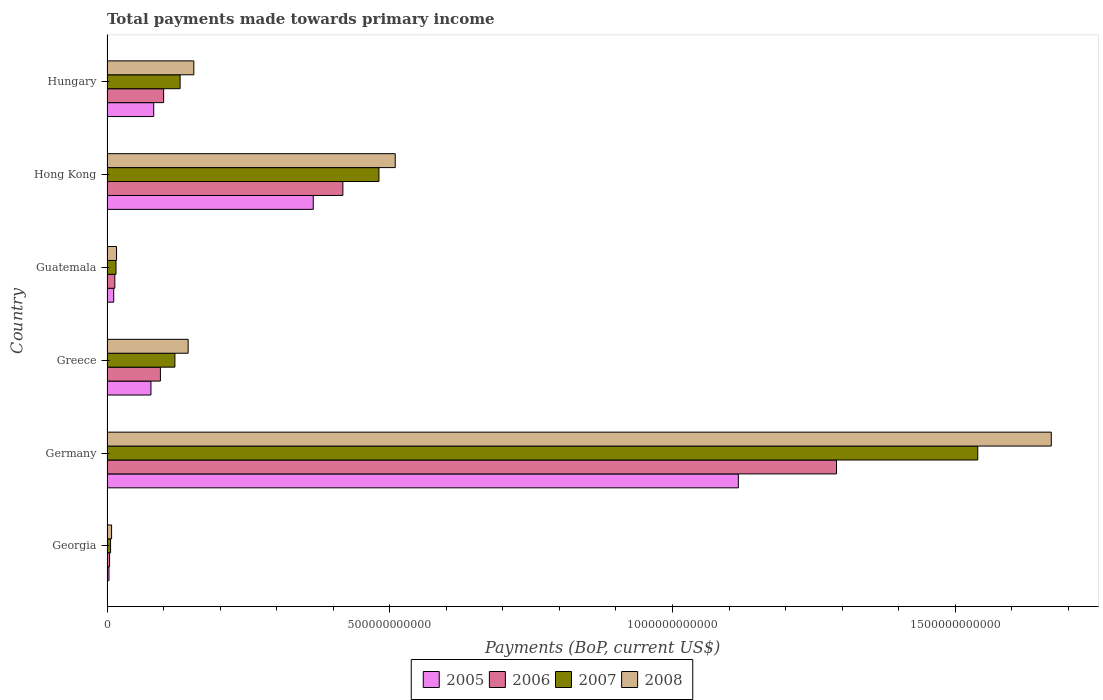How many different coloured bars are there?
Offer a very short reply. 4. How many groups of bars are there?
Give a very brief answer. 6. How many bars are there on the 3rd tick from the top?
Your answer should be compact. 4. How many bars are there on the 2nd tick from the bottom?
Provide a succinct answer. 4. What is the label of the 6th group of bars from the top?
Your answer should be compact. Georgia. What is the total payments made towards primary income in 2005 in Hong Kong?
Your answer should be compact. 3.65e+11. Across all countries, what is the maximum total payments made towards primary income in 2005?
Your answer should be very brief. 1.12e+12. Across all countries, what is the minimum total payments made towards primary income in 2005?
Your answer should be compact. 3.47e+09. In which country was the total payments made towards primary income in 2007 minimum?
Your response must be concise. Georgia. What is the total total payments made towards primary income in 2005 in the graph?
Offer a terse response. 1.66e+12. What is the difference between the total payments made towards primary income in 2007 in Georgia and that in Hong Kong?
Your answer should be compact. -4.75e+11. What is the difference between the total payments made towards primary income in 2008 in Georgia and the total payments made towards primary income in 2005 in Hong Kong?
Provide a short and direct response. -3.57e+11. What is the average total payments made towards primary income in 2008 per country?
Ensure brevity in your answer.  4.17e+11. What is the difference between the total payments made towards primary income in 2006 and total payments made towards primary income in 2007 in Greece?
Your answer should be compact. -2.56e+1. In how many countries, is the total payments made towards primary income in 2006 greater than 800000000000 US$?
Offer a terse response. 1. What is the ratio of the total payments made towards primary income in 2006 in Georgia to that in Greece?
Your answer should be very brief. 0.05. Is the total payments made towards primary income in 2008 in Georgia less than that in Hong Kong?
Offer a very short reply. Yes. What is the difference between the highest and the second highest total payments made towards primary income in 2007?
Give a very brief answer. 1.06e+12. What is the difference between the highest and the lowest total payments made towards primary income in 2006?
Give a very brief answer. 1.29e+12. Is the sum of the total payments made towards primary income in 2005 in Greece and Hungary greater than the maximum total payments made towards primary income in 2007 across all countries?
Give a very brief answer. No. What does the 3rd bar from the top in Hong Kong represents?
Give a very brief answer. 2006. How many bars are there?
Make the answer very short. 24. What is the difference between two consecutive major ticks on the X-axis?
Give a very brief answer. 5.00e+11. Are the values on the major ticks of X-axis written in scientific E-notation?
Your answer should be compact. No. Does the graph contain any zero values?
Make the answer very short. No. Does the graph contain grids?
Offer a terse response. No. Where does the legend appear in the graph?
Provide a short and direct response. Bottom center. How are the legend labels stacked?
Keep it short and to the point. Horizontal. What is the title of the graph?
Provide a short and direct response. Total payments made towards primary income. Does "1961" appear as one of the legend labels in the graph?
Provide a short and direct response. No. What is the label or title of the X-axis?
Your response must be concise. Payments (BoP, current US$). What is the label or title of the Y-axis?
Provide a succinct answer. Country. What is the Payments (BoP, current US$) of 2005 in Georgia?
Your answer should be very brief. 3.47e+09. What is the Payments (BoP, current US$) in 2006 in Georgia?
Your response must be concise. 4.56e+09. What is the Payments (BoP, current US$) of 2007 in Georgia?
Your response must be concise. 6.32e+09. What is the Payments (BoP, current US$) in 2008 in Georgia?
Your answer should be very brief. 8.11e+09. What is the Payments (BoP, current US$) of 2005 in Germany?
Your answer should be compact. 1.12e+12. What is the Payments (BoP, current US$) in 2006 in Germany?
Your answer should be compact. 1.29e+12. What is the Payments (BoP, current US$) in 2007 in Germany?
Offer a very short reply. 1.54e+12. What is the Payments (BoP, current US$) of 2008 in Germany?
Make the answer very short. 1.67e+12. What is the Payments (BoP, current US$) of 2005 in Greece?
Offer a terse response. 7.77e+1. What is the Payments (BoP, current US$) in 2006 in Greece?
Your response must be concise. 9.44e+1. What is the Payments (BoP, current US$) of 2007 in Greece?
Give a very brief answer. 1.20e+11. What is the Payments (BoP, current US$) of 2008 in Greece?
Provide a succinct answer. 1.44e+11. What is the Payments (BoP, current US$) of 2005 in Guatemala?
Give a very brief answer. 1.19e+1. What is the Payments (BoP, current US$) of 2006 in Guatemala?
Your response must be concise. 1.38e+1. What is the Payments (BoP, current US$) of 2007 in Guatemala?
Offer a terse response. 1.59e+1. What is the Payments (BoP, current US$) in 2008 in Guatemala?
Give a very brief answer. 1.69e+1. What is the Payments (BoP, current US$) in 2005 in Hong Kong?
Keep it short and to the point. 3.65e+11. What is the Payments (BoP, current US$) in 2006 in Hong Kong?
Your answer should be compact. 4.17e+11. What is the Payments (BoP, current US$) in 2007 in Hong Kong?
Offer a very short reply. 4.81e+11. What is the Payments (BoP, current US$) of 2008 in Hong Kong?
Provide a short and direct response. 5.10e+11. What is the Payments (BoP, current US$) in 2005 in Hungary?
Provide a short and direct response. 8.26e+1. What is the Payments (BoP, current US$) of 2006 in Hungary?
Provide a short and direct response. 1.00e+11. What is the Payments (BoP, current US$) in 2007 in Hungary?
Keep it short and to the point. 1.29e+11. What is the Payments (BoP, current US$) of 2008 in Hungary?
Provide a short and direct response. 1.54e+11. Across all countries, what is the maximum Payments (BoP, current US$) of 2005?
Offer a very short reply. 1.12e+12. Across all countries, what is the maximum Payments (BoP, current US$) in 2006?
Your response must be concise. 1.29e+12. Across all countries, what is the maximum Payments (BoP, current US$) of 2007?
Keep it short and to the point. 1.54e+12. Across all countries, what is the maximum Payments (BoP, current US$) of 2008?
Provide a succinct answer. 1.67e+12. Across all countries, what is the minimum Payments (BoP, current US$) of 2005?
Your answer should be very brief. 3.47e+09. Across all countries, what is the minimum Payments (BoP, current US$) in 2006?
Your answer should be very brief. 4.56e+09. Across all countries, what is the minimum Payments (BoP, current US$) in 2007?
Ensure brevity in your answer.  6.32e+09. Across all countries, what is the minimum Payments (BoP, current US$) of 2008?
Give a very brief answer. 8.11e+09. What is the total Payments (BoP, current US$) of 2005 in the graph?
Offer a very short reply. 1.66e+12. What is the total Payments (BoP, current US$) in 2006 in the graph?
Your answer should be compact. 1.92e+12. What is the total Payments (BoP, current US$) of 2007 in the graph?
Make the answer very short. 2.29e+12. What is the total Payments (BoP, current US$) in 2008 in the graph?
Keep it short and to the point. 2.50e+12. What is the difference between the Payments (BoP, current US$) in 2005 in Georgia and that in Germany?
Make the answer very short. -1.11e+12. What is the difference between the Payments (BoP, current US$) in 2006 in Georgia and that in Germany?
Your answer should be compact. -1.29e+12. What is the difference between the Payments (BoP, current US$) in 2007 in Georgia and that in Germany?
Provide a short and direct response. -1.53e+12. What is the difference between the Payments (BoP, current US$) of 2008 in Georgia and that in Germany?
Offer a very short reply. -1.66e+12. What is the difference between the Payments (BoP, current US$) of 2005 in Georgia and that in Greece?
Make the answer very short. -7.43e+1. What is the difference between the Payments (BoP, current US$) in 2006 in Georgia and that in Greece?
Provide a short and direct response. -8.99e+1. What is the difference between the Payments (BoP, current US$) in 2007 in Georgia and that in Greece?
Your answer should be compact. -1.14e+11. What is the difference between the Payments (BoP, current US$) of 2008 in Georgia and that in Greece?
Make the answer very short. -1.35e+11. What is the difference between the Payments (BoP, current US$) in 2005 in Georgia and that in Guatemala?
Provide a succinct answer. -8.42e+09. What is the difference between the Payments (BoP, current US$) of 2006 in Georgia and that in Guatemala?
Offer a terse response. -9.27e+09. What is the difference between the Payments (BoP, current US$) in 2007 in Georgia and that in Guatemala?
Give a very brief answer. -9.59e+09. What is the difference between the Payments (BoP, current US$) in 2008 in Georgia and that in Guatemala?
Offer a very short reply. -8.77e+09. What is the difference between the Payments (BoP, current US$) in 2005 in Georgia and that in Hong Kong?
Offer a very short reply. -3.61e+11. What is the difference between the Payments (BoP, current US$) in 2006 in Georgia and that in Hong Kong?
Your response must be concise. -4.13e+11. What is the difference between the Payments (BoP, current US$) in 2007 in Georgia and that in Hong Kong?
Provide a succinct answer. -4.75e+11. What is the difference between the Payments (BoP, current US$) in 2008 in Georgia and that in Hong Kong?
Ensure brevity in your answer.  -5.02e+11. What is the difference between the Payments (BoP, current US$) in 2005 in Georgia and that in Hungary?
Your response must be concise. -7.91e+1. What is the difference between the Payments (BoP, current US$) in 2006 in Georgia and that in Hungary?
Your answer should be very brief. -9.56e+1. What is the difference between the Payments (BoP, current US$) of 2007 in Georgia and that in Hungary?
Give a very brief answer. -1.23e+11. What is the difference between the Payments (BoP, current US$) of 2008 in Georgia and that in Hungary?
Keep it short and to the point. -1.45e+11. What is the difference between the Payments (BoP, current US$) in 2005 in Germany and that in Greece?
Offer a very short reply. 1.04e+12. What is the difference between the Payments (BoP, current US$) of 2006 in Germany and that in Greece?
Offer a very short reply. 1.20e+12. What is the difference between the Payments (BoP, current US$) in 2007 in Germany and that in Greece?
Offer a terse response. 1.42e+12. What is the difference between the Payments (BoP, current US$) of 2008 in Germany and that in Greece?
Offer a very short reply. 1.53e+12. What is the difference between the Payments (BoP, current US$) in 2005 in Germany and that in Guatemala?
Make the answer very short. 1.10e+12. What is the difference between the Payments (BoP, current US$) in 2006 in Germany and that in Guatemala?
Give a very brief answer. 1.28e+12. What is the difference between the Payments (BoP, current US$) in 2007 in Germany and that in Guatemala?
Make the answer very short. 1.52e+12. What is the difference between the Payments (BoP, current US$) of 2008 in Germany and that in Guatemala?
Offer a terse response. 1.65e+12. What is the difference between the Payments (BoP, current US$) in 2005 in Germany and that in Hong Kong?
Your answer should be very brief. 7.52e+11. What is the difference between the Payments (BoP, current US$) in 2006 in Germany and that in Hong Kong?
Your answer should be very brief. 8.73e+11. What is the difference between the Payments (BoP, current US$) in 2007 in Germany and that in Hong Kong?
Keep it short and to the point. 1.06e+12. What is the difference between the Payments (BoP, current US$) in 2008 in Germany and that in Hong Kong?
Keep it short and to the point. 1.16e+12. What is the difference between the Payments (BoP, current US$) of 2005 in Germany and that in Hungary?
Your answer should be very brief. 1.03e+12. What is the difference between the Payments (BoP, current US$) of 2006 in Germany and that in Hungary?
Offer a terse response. 1.19e+12. What is the difference between the Payments (BoP, current US$) of 2007 in Germany and that in Hungary?
Make the answer very short. 1.41e+12. What is the difference between the Payments (BoP, current US$) of 2008 in Germany and that in Hungary?
Ensure brevity in your answer.  1.52e+12. What is the difference between the Payments (BoP, current US$) of 2005 in Greece and that in Guatemala?
Keep it short and to the point. 6.58e+1. What is the difference between the Payments (BoP, current US$) of 2006 in Greece and that in Guatemala?
Your answer should be compact. 8.06e+1. What is the difference between the Payments (BoP, current US$) of 2007 in Greece and that in Guatemala?
Keep it short and to the point. 1.04e+11. What is the difference between the Payments (BoP, current US$) in 2008 in Greece and that in Guatemala?
Keep it short and to the point. 1.27e+11. What is the difference between the Payments (BoP, current US$) in 2005 in Greece and that in Hong Kong?
Give a very brief answer. -2.87e+11. What is the difference between the Payments (BoP, current US$) in 2006 in Greece and that in Hong Kong?
Ensure brevity in your answer.  -3.23e+11. What is the difference between the Payments (BoP, current US$) of 2007 in Greece and that in Hong Kong?
Give a very brief answer. -3.61e+11. What is the difference between the Payments (BoP, current US$) in 2008 in Greece and that in Hong Kong?
Your response must be concise. -3.66e+11. What is the difference between the Payments (BoP, current US$) of 2005 in Greece and that in Hungary?
Give a very brief answer. -4.89e+09. What is the difference between the Payments (BoP, current US$) in 2006 in Greece and that in Hungary?
Your answer should be very brief. -5.71e+09. What is the difference between the Payments (BoP, current US$) of 2007 in Greece and that in Hungary?
Your response must be concise. -9.18e+09. What is the difference between the Payments (BoP, current US$) of 2008 in Greece and that in Hungary?
Your answer should be compact. -1.00e+1. What is the difference between the Payments (BoP, current US$) in 2005 in Guatemala and that in Hong Kong?
Your response must be concise. -3.53e+11. What is the difference between the Payments (BoP, current US$) of 2006 in Guatemala and that in Hong Kong?
Give a very brief answer. -4.03e+11. What is the difference between the Payments (BoP, current US$) in 2007 in Guatemala and that in Hong Kong?
Offer a very short reply. -4.65e+11. What is the difference between the Payments (BoP, current US$) in 2008 in Guatemala and that in Hong Kong?
Ensure brevity in your answer.  -4.93e+11. What is the difference between the Payments (BoP, current US$) of 2005 in Guatemala and that in Hungary?
Offer a terse response. -7.07e+1. What is the difference between the Payments (BoP, current US$) in 2006 in Guatemala and that in Hungary?
Offer a very short reply. -8.63e+1. What is the difference between the Payments (BoP, current US$) of 2007 in Guatemala and that in Hungary?
Your answer should be compact. -1.13e+11. What is the difference between the Payments (BoP, current US$) in 2008 in Guatemala and that in Hungary?
Provide a succinct answer. -1.37e+11. What is the difference between the Payments (BoP, current US$) of 2005 in Hong Kong and that in Hungary?
Provide a succinct answer. 2.82e+11. What is the difference between the Payments (BoP, current US$) in 2006 in Hong Kong and that in Hungary?
Offer a terse response. 3.17e+11. What is the difference between the Payments (BoP, current US$) in 2007 in Hong Kong and that in Hungary?
Make the answer very short. 3.52e+11. What is the difference between the Payments (BoP, current US$) in 2008 in Hong Kong and that in Hungary?
Your answer should be compact. 3.56e+11. What is the difference between the Payments (BoP, current US$) in 2005 in Georgia and the Payments (BoP, current US$) in 2006 in Germany?
Make the answer very short. -1.29e+12. What is the difference between the Payments (BoP, current US$) in 2005 in Georgia and the Payments (BoP, current US$) in 2007 in Germany?
Make the answer very short. -1.54e+12. What is the difference between the Payments (BoP, current US$) of 2005 in Georgia and the Payments (BoP, current US$) of 2008 in Germany?
Your response must be concise. -1.67e+12. What is the difference between the Payments (BoP, current US$) in 2006 in Georgia and the Payments (BoP, current US$) in 2007 in Germany?
Ensure brevity in your answer.  -1.54e+12. What is the difference between the Payments (BoP, current US$) of 2006 in Georgia and the Payments (BoP, current US$) of 2008 in Germany?
Ensure brevity in your answer.  -1.67e+12. What is the difference between the Payments (BoP, current US$) of 2007 in Georgia and the Payments (BoP, current US$) of 2008 in Germany?
Keep it short and to the point. -1.66e+12. What is the difference between the Payments (BoP, current US$) in 2005 in Georgia and the Payments (BoP, current US$) in 2006 in Greece?
Offer a very short reply. -9.10e+1. What is the difference between the Payments (BoP, current US$) in 2005 in Georgia and the Payments (BoP, current US$) in 2007 in Greece?
Keep it short and to the point. -1.17e+11. What is the difference between the Payments (BoP, current US$) of 2005 in Georgia and the Payments (BoP, current US$) of 2008 in Greece?
Your answer should be very brief. -1.40e+11. What is the difference between the Payments (BoP, current US$) in 2006 in Georgia and the Payments (BoP, current US$) in 2007 in Greece?
Keep it short and to the point. -1.16e+11. What is the difference between the Payments (BoP, current US$) of 2006 in Georgia and the Payments (BoP, current US$) of 2008 in Greece?
Ensure brevity in your answer.  -1.39e+11. What is the difference between the Payments (BoP, current US$) of 2007 in Georgia and the Payments (BoP, current US$) of 2008 in Greece?
Ensure brevity in your answer.  -1.37e+11. What is the difference between the Payments (BoP, current US$) of 2005 in Georgia and the Payments (BoP, current US$) of 2006 in Guatemala?
Your answer should be compact. -1.04e+1. What is the difference between the Payments (BoP, current US$) of 2005 in Georgia and the Payments (BoP, current US$) of 2007 in Guatemala?
Your answer should be very brief. -1.24e+1. What is the difference between the Payments (BoP, current US$) in 2005 in Georgia and the Payments (BoP, current US$) in 2008 in Guatemala?
Provide a succinct answer. -1.34e+1. What is the difference between the Payments (BoP, current US$) in 2006 in Georgia and the Payments (BoP, current US$) in 2007 in Guatemala?
Ensure brevity in your answer.  -1.14e+1. What is the difference between the Payments (BoP, current US$) in 2006 in Georgia and the Payments (BoP, current US$) in 2008 in Guatemala?
Keep it short and to the point. -1.23e+1. What is the difference between the Payments (BoP, current US$) in 2007 in Georgia and the Payments (BoP, current US$) in 2008 in Guatemala?
Your answer should be very brief. -1.06e+1. What is the difference between the Payments (BoP, current US$) of 2005 in Georgia and the Payments (BoP, current US$) of 2006 in Hong Kong?
Keep it short and to the point. -4.14e+11. What is the difference between the Payments (BoP, current US$) of 2005 in Georgia and the Payments (BoP, current US$) of 2007 in Hong Kong?
Your response must be concise. -4.77e+11. What is the difference between the Payments (BoP, current US$) of 2005 in Georgia and the Payments (BoP, current US$) of 2008 in Hong Kong?
Provide a short and direct response. -5.06e+11. What is the difference between the Payments (BoP, current US$) of 2006 in Georgia and the Payments (BoP, current US$) of 2007 in Hong Kong?
Make the answer very short. -4.76e+11. What is the difference between the Payments (BoP, current US$) of 2006 in Georgia and the Payments (BoP, current US$) of 2008 in Hong Kong?
Give a very brief answer. -5.05e+11. What is the difference between the Payments (BoP, current US$) of 2007 in Georgia and the Payments (BoP, current US$) of 2008 in Hong Kong?
Offer a terse response. -5.03e+11. What is the difference between the Payments (BoP, current US$) in 2005 in Georgia and the Payments (BoP, current US$) in 2006 in Hungary?
Your answer should be compact. -9.67e+1. What is the difference between the Payments (BoP, current US$) in 2005 in Georgia and the Payments (BoP, current US$) in 2007 in Hungary?
Keep it short and to the point. -1.26e+11. What is the difference between the Payments (BoP, current US$) of 2005 in Georgia and the Payments (BoP, current US$) of 2008 in Hungary?
Offer a very short reply. -1.50e+11. What is the difference between the Payments (BoP, current US$) of 2006 in Georgia and the Payments (BoP, current US$) of 2007 in Hungary?
Offer a terse response. -1.25e+11. What is the difference between the Payments (BoP, current US$) of 2006 in Georgia and the Payments (BoP, current US$) of 2008 in Hungary?
Your response must be concise. -1.49e+11. What is the difference between the Payments (BoP, current US$) in 2007 in Georgia and the Payments (BoP, current US$) in 2008 in Hungary?
Offer a very short reply. -1.47e+11. What is the difference between the Payments (BoP, current US$) of 2005 in Germany and the Payments (BoP, current US$) of 2006 in Greece?
Offer a very short reply. 1.02e+12. What is the difference between the Payments (BoP, current US$) in 2005 in Germany and the Payments (BoP, current US$) in 2007 in Greece?
Offer a very short reply. 9.96e+11. What is the difference between the Payments (BoP, current US$) of 2005 in Germany and the Payments (BoP, current US$) of 2008 in Greece?
Make the answer very short. 9.73e+11. What is the difference between the Payments (BoP, current US$) in 2006 in Germany and the Payments (BoP, current US$) in 2007 in Greece?
Make the answer very short. 1.17e+12. What is the difference between the Payments (BoP, current US$) in 2006 in Germany and the Payments (BoP, current US$) in 2008 in Greece?
Offer a terse response. 1.15e+12. What is the difference between the Payments (BoP, current US$) of 2007 in Germany and the Payments (BoP, current US$) of 2008 in Greece?
Your answer should be compact. 1.40e+12. What is the difference between the Payments (BoP, current US$) in 2005 in Germany and the Payments (BoP, current US$) in 2006 in Guatemala?
Ensure brevity in your answer.  1.10e+12. What is the difference between the Payments (BoP, current US$) of 2005 in Germany and the Payments (BoP, current US$) of 2007 in Guatemala?
Your answer should be very brief. 1.10e+12. What is the difference between the Payments (BoP, current US$) in 2005 in Germany and the Payments (BoP, current US$) in 2008 in Guatemala?
Your response must be concise. 1.10e+12. What is the difference between the Payments (BoP, current US$) in 2006 in Germany and the Payments (BoP, current US$) in 2007 in Guatemala?
Offer a terse response. 1.27e+12. What is the difference between the Payments (BoP, current US$) in 2006 in Germany and the Payments (BoP, current US$) in 2008 in Guatemala?
Your answer should be very brief. 1.27e+12. What is the difference between the Payments (BoP, current US$) of 2007 in Germany and the Payments (BoP, current US$) of 2008 in Guatemala?
Your answer should be compact. 1.52e+12. What is the difference between the Payments (BoP, current US$) in 2005 in Germany and the Payments (BoP, current US$) in 2006 in Hong Kong?
Ensure brevity in your answer.  6.99e+11. What is the difference between the Payments (BoP, current US$) of 2005 in Germany and the Payments (BoP, current US$) of 2007 in Hong Kong?
Ensure brevity in your answer.  6.36e+11. What is the difference between the Payments (BoP, current US$) of 2005 in Germany and the Payments (BoP, current US$) of 2008 in Hong Kong?
Make the answer very short. 6.07e+11. What is the difference between the Payments (BoP, current US$) of 2006 in Germany and the Payments (BoP, current US$) of 2007 in Hong Kong?
Your response must be concise. 8.09e+11. What is the difference between the Payments (BoP, current US$) in 2006 in Germany and the Payments (BoP, current US$) in 2008 in Hong Kong?
Offer a terse response. 7.80e+11. What is the difference between the Payments (BoP, current US$) of 2007 in Germany and the Payments (BoP, current US$) of 2008 in Hong Kong?
Keep it short and to the point. 1.03e+12. What is the difference between the Payments (BoP, current US$) of 2005 in Germany and the Payments (BoP, current US$) of 2006 in Hungary?
Provide a short and direct response. 1.02e+12. What is the difference between the Payments (BoP, current US$) of 2005 in Germany and the Payments (BoP, current US$) of 2007 in Hungary?
Provide a short and direct response. 9.87e+11. What is the difference between the Payments (BoP, current US$) in 2005 in Germany and the Payments (BoP, current US$) in 2008 in Hungary?
Make the answer very short. 9.63e+11. What is the difference between the Payments (BoP, current US$) of 2006 in Germany and the Payments (BoP, current US$) of 2007 in Hungary?
Your response must be concise. 1.16e+12. What is the difference between the Payments (BoP, current US$) of 2006 in Germany and the Payments (BoP, current US$) of 2008 in Hungary?
Provide a short and direct response. 1.14e+12. What is the difference between the Payments (BoP, current US$) of 2007 in Germany and the Payments (BoP, current US$) of 2008 in Hungary?
Make the answer very short. 1.39e+12. What is the difference between the Payments (BoP, current US$) of 2005 in Greece and the Payments (BoP, current US$) of 2006 in Guatemala?
Your answer should be very brief. 6.39e+1. What is the difference between the Payments (BoP, current US$) of 2005 in Greece and the Payments (BoP, current US$) of 2007 in Guatemala?
Offer a very short reply. 6.18e+1. What is the difference between the Payments (BoP, current US$) in 2005 in Greece and the Payments (BoP, current US$) in 2008 in Guatemala?
Keep it short and to the point. 6.08e+1. What is the difference between the Payments (BoP, current US$) in 2006 in Greece and the Payments (BoP, current US$) in 2007 in Guatemala?
Your answer should be very brief. 7.85e+1. What is the difference between the Payments (BoP, current US$) in 2006 in Greece and the Payments (BoP, current US$) in 2008 in Guatemala?
Provide a succinct answer. 7.76e+1. What is the difference between the Payments (BoP, current US$) in 2007 in Greece and the Payments (BoP, current US$) in 2008 in Guatemala?
Ensure brevity in your answer.  1.03e+11. What is the difference between the Payments (BoP, current US$) in 2005 in Greece and the Payments (BoP, current US$) in 2006 in Hong Kong?
Provide a succinct answer. -3.39e+11. What is the difference between the Payments (BoP, current US$) of 2005 in Greece and the Payments (BoP, current US$) of 2007 in Hong Kong?
Make the answer very short. -4.03e+11. What is the difference between the Payments (BoP, current US$) in 2005 in Greece and the Payments (BoP, current US$) in 2008 in Hong Kong?
Give a very brief answer. -4.32e+11. What is the difference between the Payments (BoP, current US$) in 2006 in Greece and the Payments (BoP, current US$) in 2007 in Hong Kong?
Offer a very short reply. -3.86e+11. What is the difference between the Payments (BoP, current US$) of 2006 in Greece and the Payments (BoP, current US$) of 2008 in Hong Kong?
Offer a terse response. -4.15e+11. What is the difference between the Payments (BoP, current US$) in 2007 in Greece and the Payments (BoP, current US$) in 2008 in Hong Kong?
Your answer should be compact. -3.90e+11. What is the difference between the Payments (BoP, current US$) in 2005 in Greece and the Payments (BoP, current US$) in 2006 in Hungary?
Your answer should be very brief. -2.24e+1. What is the difference between the Payments (BoP, current US$) in 2005 in Greece and the Payments (BoP, current US$) in 2007 in Hungary?
Ensure brevity in your answer.  -5.16e+1. What is the difference between the Payments (BoP, current US$) in 2005 in Greece and the Payments (BoP, current US$) in 2008 in Hungary?
Keep it short and to the point. -7.58e+1. What is the difference between the Payments (BoP, current US$) in 2006 in Greece and the Payments (BoP, current US$) in 2007 in Hungary?
Provide a short and direct response. -3.48e+1. What is the difference between the Payments (BoP, current US$) of 2006 in Greece and the Payments (BoP, current US$) of 2008 in Hungary?
Your answer should be very brief. -5.91e+1. What is the difference between the Payments (BoP, current US$) in 2007 in Greece and the Payments (BoP, current US$) in 2008 in Hungary?
Provide a short and direct response. -3.34e+1. What is the difference between the Payments (BoP, current US$) of 2005 in Guatemala and the Payments (BoP, current US$) of 2006 in Hong Kong?
Give a very brief answer. -4.05e+11. What is the difference between the Payments (BoP, current US$) of 2005 in Guatemala and the Payments (BoP, current US$) of 2007 in Hong Kong?
Your answer should be very brief. -4.69e+11. What is the difference between the Payments (BoP, current US$) of 2005 in Guatemala and the Payments (BoP, current US$) of 2008 in Hong Kong?
Give a very brief answer. -4.98e+11. What is the difference between the Payments (BoP, current US$) of 2006 in Guatemala and the Payments (BoP, current US$) of 2007 in Hong Kong?
Provide a succinct answer. -4.67e+11. What is the difference between the Payments (BoP, current US$) in 2006 in Guatemala and the Payments (BoP, current US$) in 2008 in Hong Kong?
Provide a short and direct response. -4.96e+11. What is the difference between the Payments (BoP, current US$) in 2007 in Guatemala and the Payments (BoP, current US$) in 2008 in Hong Kong?
Your answer should be compact. -4.94e+11. What is the difference between the Payments (BoP, current US$) of 2005 in Guatemala and the Payments (BoP, current US$) of 2006 in Hungary?
Provide a short and direct response. -8.83e+1. What is the difference between the Payments (BoP, current US$) of 2005 in Guatemala and the Payments (BoP, current US$) of 2007 in Hungary?
Keep it short and to the point. -1.17e+11. What is the difference between the Payments (BoP, current US$) of 2005 in Guatemala and the Payments (BoP, current US$) of 2008 in Hungary?
Offer a very short reply. -1.42e+11. What is the difference between the Payments (BoP, current US$) of 2006 in Guatemala and the Payments (BoP, current US$) of 2007 in Hungary?
Make the answer very short. -1.15e+11. What is the difference between the Payments (BoP, current US$) of 2006 in Guatemala and the Payments (BoP, current US$) of 2008 in Hungary?
Your response must be concise. -1.40e+11. What is the difference between the Payments (BoP, current US$) of 2007 in Guatemala and the Payments (BoP, current US$) of 2008 in Hungary?
Offer a terse response. -1.38e+11. What is the difference between the Payments (BoP, current US$) of 2005 in Hong Kong and the Payments (BoP, current US$) of 2006 in Hungary?
Make the answer very short. 2.65e+11. What is the difference between the Payments (BoP, current US$) in 2005 in Hong Kong and the Payments (BoP, current US$) in 2007 in Hungary?
Provide a succinct answer. 2.35e+11. What is the difference between the Payments (BoP, current US$) of 2005 in Hong Kong and the Payments (BoP, current US$) of 2008 in Hungary?
Keep it short and to the point. 2.11e+11. What is the difference between the Payments (BoP, current US$) of 2006 in Hong Kong and the Payments (BoP, current US$) of 2007 in Hungary?
Offer a very short reply. 2.88e+11. What is the difference between the Payments (BoP, current US$) in 2006 in Hong Kong and the Payments (BoP, current US$) in 2008 in Hungary?
Offer a very short reply. 2.64e+11. What is the difference between the Payments (BoP, current US$) of 2007 in Hong Kong and the Payments (BoP, current US$) of 2008 in Hungary?
Provide a short and direct response. 3.27e+11. What is the average Payments (BoP, current US$) of 2005 per country?
Provide a short and direct response. 2.76e+11. What is the average Payments (BoP, current US$) of 2006 per country?
Make the answer very short. 3.20e+11. What is the average Payments (BoP, current US$) of 2007 per country?
Ensure brevity in your answer.  3.82e+11. What is the average Payments (BoP, current US$) in 2008 per country?
Provide a short and direct response. 4.17e+11. What is the difference between the Payments (BoP, current US$) of 2005 and Payments (BoP, current US$) of 2006 in Georgia?
Your response must be concise. -1.09e+09. What is the difference between the Payments (BoP, current US$) of 2005 and Payments (BoP, current US$) of 2007 in Georgia?
Provide a succinct answer. -2.86e+09. What is the difference between the Payments (BoP, current US$) of 2005 and Payments (BoP, current US$) of 2008 in Georgia?
Your response must be concise. -4.65e+09. What is the difference between the Payments (BoP, current US$) in 2006 and Payments (BoP, current US$) in 2007 in Georgia?
Provide a short and direct response. -1.77e+09. What is the difference between the Payments (BoP, current US$) of 2006 and Payments (BoP, current US$) of 2008 in Georgia?
Provide a short and direct response. -3.56e+09. What is the difference between the Payments (BoP, current US$) of 2007 and Payments (BoP, current US$) of 2008 in Georgia?
Your answer should be compact. -1.79e+09. What is the difference between the Payments (BoP, current US$) of 2005 and Payments (BoP, current US$) of 2006 in Germany?
Provide a short and direct response. -1.74e+11. What is the difference between the Payments (BoP, current US$) of 2005 and Payments (BoP, current US$) of 2007 in Germany?
Make the answer very short. -4.23e+11. What is the difference between the Payments (BoP, current US$) in 2005 and Payments (BoP, current US$) in 2008 in Germany?
Make the answer very short. -5.53e+11. What is the difference between the Payments (BoP, current US$) of 2006 and Payments (BoP, current US$) of 2007 in Germany?
Your answer should be compact. -2.50e+11. What is the difference between the Payments (BoP, current US$) in 2006 and Payments (BoP, current US$) in 2008 in Germany?
Keep it short and to the point. -3.80e+11. What is the difference between the Payments (BoP, current US$) of 2007 and Payments (BoP, current US$) of 2008 in Germany?
Your response must be concise. -1.30e+11. What is the difference between the Payments (BoP, current US$) of 2005 and Payments (BoP, current US$) of 2006 in Greece?
Offer a very short reply. -1.67e+1. What is the difference between the Payments (BoP, current US$) in 2005 and Payments (BoP, current US$) in 2007 in Greece?
Provide a short and direct response. -4.24e+1. What is the difference between the Payments (BoP, current US$) of 2005 and Payments (BoP, current US$) of 2008 in Greece?
Your answer should be compact. -6.58e+1. What is the difference between the Payments (BoP, current US$) in 2006 and Payments (BoP, current US$) in 2007 in Greece?
Offer a very short reply. -2.56e+1. What is the difference between the Payments (BoP, current US$) of 2006 and Payments (BoP, current US$) of 2008 in Greece?
Make the answer very short. -4.91e+1. What is the difference between the Payments (BoP, current US$) in 2007 and Payments (BoP, current US$) in 2008 in Greece?
Make the answer very short. -2.34e+1. What is the difference between the Payments (BoP, current US$) of 2005 and Payments (BoP, current US$) of 2006 in Guatemala?
Give a very brief answer. -1.94e+09. What is the difference between the Payments (BoP, current US$) in 2005 and Payments (BoP, current US$) in 2007 in Guatemala?
Your answer should be very brief. -4.02e+09. What is the difference between the Payments (BoP, current US$) in 2005 and Payments (BoP, current US$) in 2008 in Guatemala?
Make the answer very short. -5.00e+09. What is the difference between the Payments (BoP, current US$) of 2006 and Payments (BoP, current US$) of 2007 in Guatemala?
Your answer should be very brief. -2.08e+09. What is the difference between the Payments (BoP, current US$) in 2006 and Payments (BoP, current US$) in 2008 in Guatemala?
Your answer should be very brief. -3.06e+09. What is the difference between the Payments (BoP, current US$) of 2007 and Payments (BoP, current US$) of 2008 in Guatemala?
Your answer should be compact. -9.78e+08. What is the difference between the Payments (BoP, current US$) in 2005 and Payments (BoP, current US$) in 2006 in Hong Kong?
Offer a terse response. -5.24e+1. What is the difference between the Payments (BoP, current US$) in 2005 and Payments (BoP, current US$) in 2007 in Hong Kong?
Keep it short and to the point. -1.16e+11. What is the difference between the Payments (BoP, current US$) in 2005 and Payments (BoP, current US$) in 2008 in Hong Kong?
Offer a very short reply. -1.45e+11. What is the difference between the Payments (BoP, current US$) in 2006 and Payments (BoP, current US$) in 2007 in Hong Kong?
Make the answer very short. -6.38e+1. What is the difference between the Payments (BoP, current US$) of 2006 and Payments (BoP, current US$) of 2008 in Hong Kong?
Provide a short and direct response. -9.26e+1. What is the difference between the Payments (BoP, current US$) of 2007 and Payments (BoP, current US$) of 2008 in Hong Kong?
Give a very brief answer. -2.88e+1. What is the difference between the Payments (BoP, current US$) in 2005 and Payments (BoP, current US$) in 2006 in Hungary?
Provide a short and direct response. -1.75e+1. What is the difference between the Payments (BoP, current US$) of 2005 and Payments (BoP, current US$) of 2007 in Hungary?
Make the answer very short. -4.67e+1. What is the difference between the Payments (BoP, current US$) in 2005 and Payments (BoP, current US$) in 2008 in Hungary?
Make the answer very short. -7.09e+1. What is the difference between the Payments (BoP, current US$) in 2006 and Payments (BoP, current US$) in 2007 in Hungary?
Offer a terse response. -2.91e+1. What is the difference between the Payments (BoP, current US$) of 2006 and Payments (BoP, current US$) of 2008 in Hungary?
Your answer should be very brief. -5.34e+1. What is the difference between the Payments (BoP, current US$) in 2007 and Payments (BoP, current US$) in 2008 in Hungary?
Your response must be concise. -2.43e+1. What is the ratio of the Payments (BoP, current US$) in 2005 in Georgia to that in Germany?
Provide a short and direct response. 0. What is the ratio of the Payments (BoP, current US$) in 2006 in Georgia to that in Germany?
Your answer should be very brief. 0. What is the ratio of the Payments (BoP, current US$) in 2007 in Georgia to that in Germany?
Keep it short and to the point. 0. What is the ratio of the Payments (BoP, current US$) in 2008 in Georgia to that in Germany?
Offer a terse response. 0. What is the ratio of the Payments (BoP, current US$) in 2005 in Georgia to that in Greece?
Your answer should be compact. 0.04. What is the ratio of the Payments (BoP, current US$) in 2006 in Georgia to that in Greece?
Ensure brevity in your answer.  0.05. What is the ratio of the Payments (BoP, current US$) in 2007 in Georgia to that in Greece?
Your answer should be compact. 0.05. What is the ratio of the Payments (BoP, current US$) in 2008 in Georgia to that in Greece?
Your answer should be very brief. 0.06. What is the ratio of the Payments (BoP, current US$) in 2005 in Georgia to that in Guatemala?
Offer a terse response. 0.29. What is the ratio of the Payments (BoP, current US$) in 2006 in Georgia to that in Guatemala?
Keep it short and to the point. 0.33. What is the ratio of the Payments (BoP, current US$) in 2007 in Georgia to that in Guatemala?
Keep it short and to the point. 0.4. What is the ratio of the Payments (BoP, current US$) in 2008 in Georgia to that in Guatemala?
Your response must be concise. 0.48. What is the ratio of the Payments (BoP, current US$) of 2005 in Georgia to that in Hong Kong?
Your answer should be compact. 0.01. What is the ratio of the Payments (BoP, current US$) of 2006 in Georgia to that in Hong Kong?
Provide a short and direct response. 0.01. What is the ratio of the Payments (BoP, current US$) in 2007 in Georgia to that in Hong Kong?
Your answer should be compact. 0.01. What is the ratio of the Payments (BoP, current US$) of 2008 in Georgia to that in Hong Kong?
Make the answer very short. 0.02. What is the ratio of the Payments (BoP, current US$) of 2005 in Georgia to that in Hungary?
Your answer should be very brief. 0.04. What is the ratio of the Payments (BoP, current US$) in 2006 in Georgia to that in Hungary?
Offer a terse response. 0.05. What is the ratio of the Payments (BoP, current US$) in 2007 in Georgia to that in Hungary?
Give a very brief answer. 0.05. What is the ratio of the Payments (BoP, current US$) in 2008 in Georgia to that in Hungary?
Offer a terse response. 0.05. What is the ratio of the Payments (BoP, current US$) of 2005 in Germany to that in Greece?
Your answer should be very brief. 14.37. What is the ratio of the Payments (BoP, current US$) of 2006 in Germany to that in Greece?
Make the answer very short. 13.66. What is the ratio of the Payments (BoP, current US$) in 2007 in Germany to that in Greece?
Make the answer very short. 12.82. What is the ratio of the Payments (BoP, current US$) in 2008 in Germany to that in Greece?
Ensure brevity in your answer.  11.64. What is the ratio of the Payments (BoP, current US$) in 2005 in Germany to that in Guatemala?
Your answer should be very brief. 93.94. What is the ratio of the Payments (BoP, current US$) of 2006 in Germany to that in Guatemala?
Provide a short and direct response. 93.3. What is the ratio of the Payments (BoP, current US$) of 2007 in Germany to that in Guatemala?
Your response must be concise. 96.79. What is the ratio of the Payments (BoP, current US$) of 2008 in Germany to that in Guatemala?
Provide a succinct answer. 98.88. What is the ratio of the Payments (BoP, current US$) in 2005 in Germany to that in Hong Kong?
Ensure brevity in your answer.  3.06. What is the ratio of the Payments (BoP, current US$) in 2006 in Germany to that in Hong Kong?
Make the answer very short. 3.09. What is the ratio of the Payments (BoP, current US$) in 2007 in Germany to that in Hong Kong?
Offer a very short reply. 3.2. What is the ratio of the Payments (BoP, current US$) in 2008 in Germany to that in Hong Kong?
Give a very brief answer. 3.28. What is the ratio of the Payments (BoP, current US$) in 2005 in Germany to that in Hungary?
Your answer should be compact. 13.52. What is the ratio of the Payments (BoP, current US$) of 2006 in Germany to that in Hungary?
Keep it short and to the point. 12.88. What is the ratio of the Payments (BoP, current US$) of 2007 in Germany to that in Hungary?
Give a very brief answer. 11.91. What is the ratio of the Payments (BoP, current US$) of 2008 in Germany to that in Hungary?
Provide a succinct answer. 10.88. What is the ratio of the Payments (BoP, current US$) in 2005 in Greece to that in Guatemala?
Offer a terse response. 6.54. What is the ratio of the Payments (BoP, current US$) of 2006 in Greece to that in Guatemala?
Offer a terse response. 6.83. What is the ratio of the Payments (BoP, current US$) of 2007 in Greece to that in Guatemala?
Ensure brevity in your answer.  7.55. What is the ratio of the Payments (BoP, current US$) of 2008 in Greece to that in Guatemala?
Make the answer very short. 8.5. What is the ratio of the Payments (BoP, current US$) in 2005 in Greece to that in Hong Kong?
Make the answer very short. 0.21. What is the ratio of the Payments (BoP, current US$) in 2006 in Greece to that in Hong Kong?
Your response must be concise. 0.23. What is the ratio of the Payments (BoP, current US$) of 2007 in Greece to that in Hong Kong?
Provide a succinct answer. 0.25. What is the ratio of the Payments (BoP, current US$) in 2008 in Greece to that in Hong Kong?
Keep it short and to the point. 0.28. What is the ratio of the Payments (BoP, current US$) of 2005 in Greece to that in Hungary?
Give a very brief answer. 0.94. What is the ratio of the Payments (BoP, current US$) of 2006 in Greece to that in Hungary?
Give a very brief answer. 0.94. What is the ratio of the Payments (BoP, current US$) of 2007 in Greece to that in Hungary?
Provide a succinct answer. 0.93. What is the ratio of the Payments (BoP, current US$) in 2008 in Greece to that in Hungary?
Provide a succinct answer. 0.93. What is the ratio of the Payments (BoP, current US$) of 2005 in Guatemala to that in Hong Kong?
Keep it short and to the point. 0.03. What is the ratio of the Payments (BoP, current US$) of 2006 in Guatemala to that in Hong Kong?
Offer a terse response. 0.03. What is the ratio of the Payments (BoP, current US$) of 2007 in Guatemala to that in Hong Kong?
Ensure brevity in your answer.  0.03. What is the ratio of the Payments (BoP, current US$) in 2008 in Guatemala to that in Hong Kong?
Keep it short and to the point. 0.03. What is the ratio of the Payments (BoP, current US$) in 2005 in Guatemala to that in Hungary?
Offer a terse response. 0.14. What is the ratio of the Payments (BoP, current US$) of 2006 in Guatemala to that in Hungary?
Offer a very short reply. 0.14. What is the ratio of the Payments (BoP, current US$) in 2007 in Guatemala to that in Hungary?
Offer a very short reply. 0.12. What is the ratio of the Payments (BoP, current US$) of 2008 in Guatemala to that in Hungary?
Your answer should be very brief. 0.11. What is the ratio of the Payments (BoP, current US$) in 2005 in Hong Kong to that in Hungary?
Make the answer very short. 4.42. What is the ratio of the Payments (BoP, current US$) of 2006 in Hong Kong to that in Hungary?
Your response must be concise. 4.17. What is the ratio of the Payments (BoP, current US$) of 2007 in Hong Kong to that in Hungary?
Offer a very short reply. 3.72. What is the ratio of the Payments (BoP, current US$) in 2008 in Hong Kong to that in Hungary?
Keep it short and to the point. 3.32. What is the difference between the highest and the second highest Payments (BoP, current US$) in 2005?
Provide a succinct answer. 7.52e+11. What is the difference between the highest and the second highest Payments (BoP, current US$) in 2006?
Your response must be concise. 8.73e+11. What is the difference between the highest and the second highest Payments (BoP, current US$) in 2007?
Your response must be concise. 1.06e+12. What is the difference between the highest and the second highest Payments (BoP, current US$) in 2008?
Your answer should be very brief. 1.16e+12. What is the difference between the highest and the lowest Payments (BoP, current US$) of 2005?
Keep it short and to the point. 1.11e+12. What is the difference between the highest and the lowest Payments (BoP, current US$) in 2006?
Give a very brief answer. 1.29e+12. What is the difference between the highest and the lowest Payments (BoP, current US$) in 2007?
Ensure brevity in your answer.  1.53e+12. What is the difference between the highest and the lowest Payments (BoP, current US$) of 2008?
Give a very brief answer. 1.66e+12. 